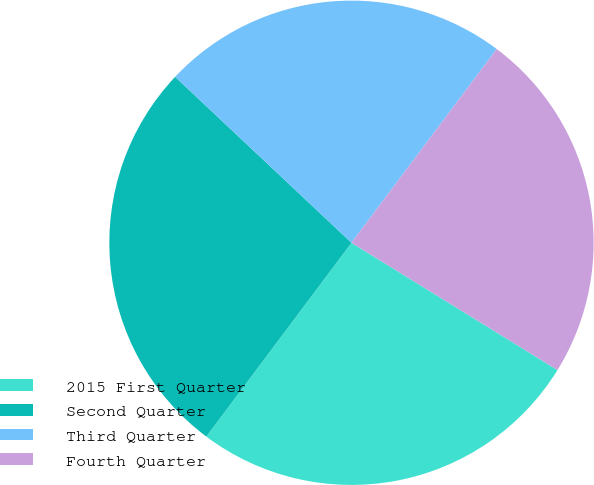<chart> <loc_0><loc_0><loc_500><loc_500><pie_chart><fcel>2015 First Quarter<fcel>Second Quarter<fcel>Third Quarter<fcel>Fourth Quarter<nl><fcel>26.42%<fcel>26.78%<fcel>23.22%<fcel>23.57%<nl></chart> 